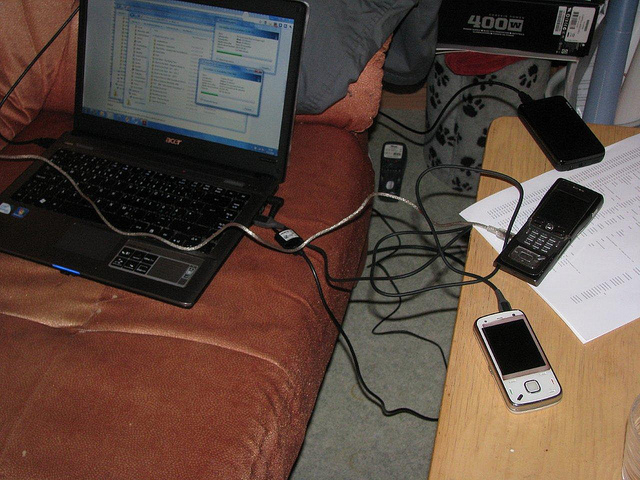<image>What brand is the phone? I don't know what brand the phone is. It could be Apple, Samsung, iPhone, LG or Nokia. What brand is the phone? I don't know the brand of the phone. It can be either Apple, Samsung, iPhone, LG or Nokia. 